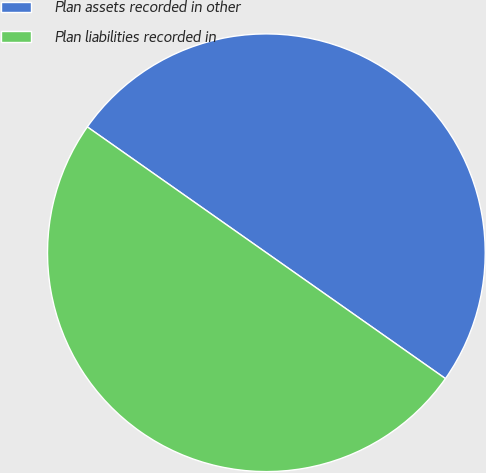Convert chart. <chart><loc_0><loc_0><loc_500><loc_500><pie_chart><fcel>Plan assets recorded in other<fcel>Plan liabilities recorded in<nl><fcel>50.0%<fcel>50.0%<nl></chart> 